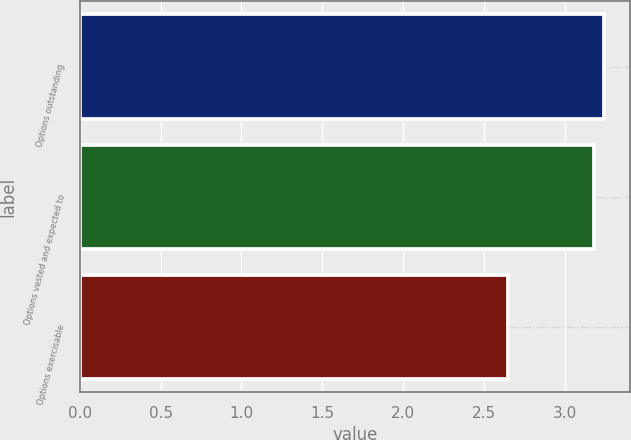<chart> <loc_0><loc_0><loc_500><loc_500><bar_chart><fcel>Options outstanding<fcel>Options vested and expected to<fcel>Options exercisable<nl><fcel>3.24<fcel>3.18<fcel>2.65<nl></chart> 